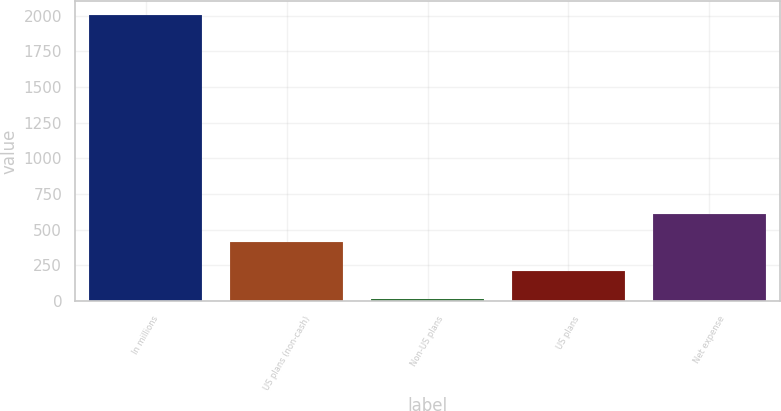<chart> <loc_0><loc_0><loc_500><loc_500><bar_chart><fcel>In millions<fcel>US plans (non-cash)<fcel>Non-US plans<fcel>US plans<fcel>Net expense<nl><fcel>2005<fcel>413<fcel>15<fcel>214<fcel>612<nl></chart> 